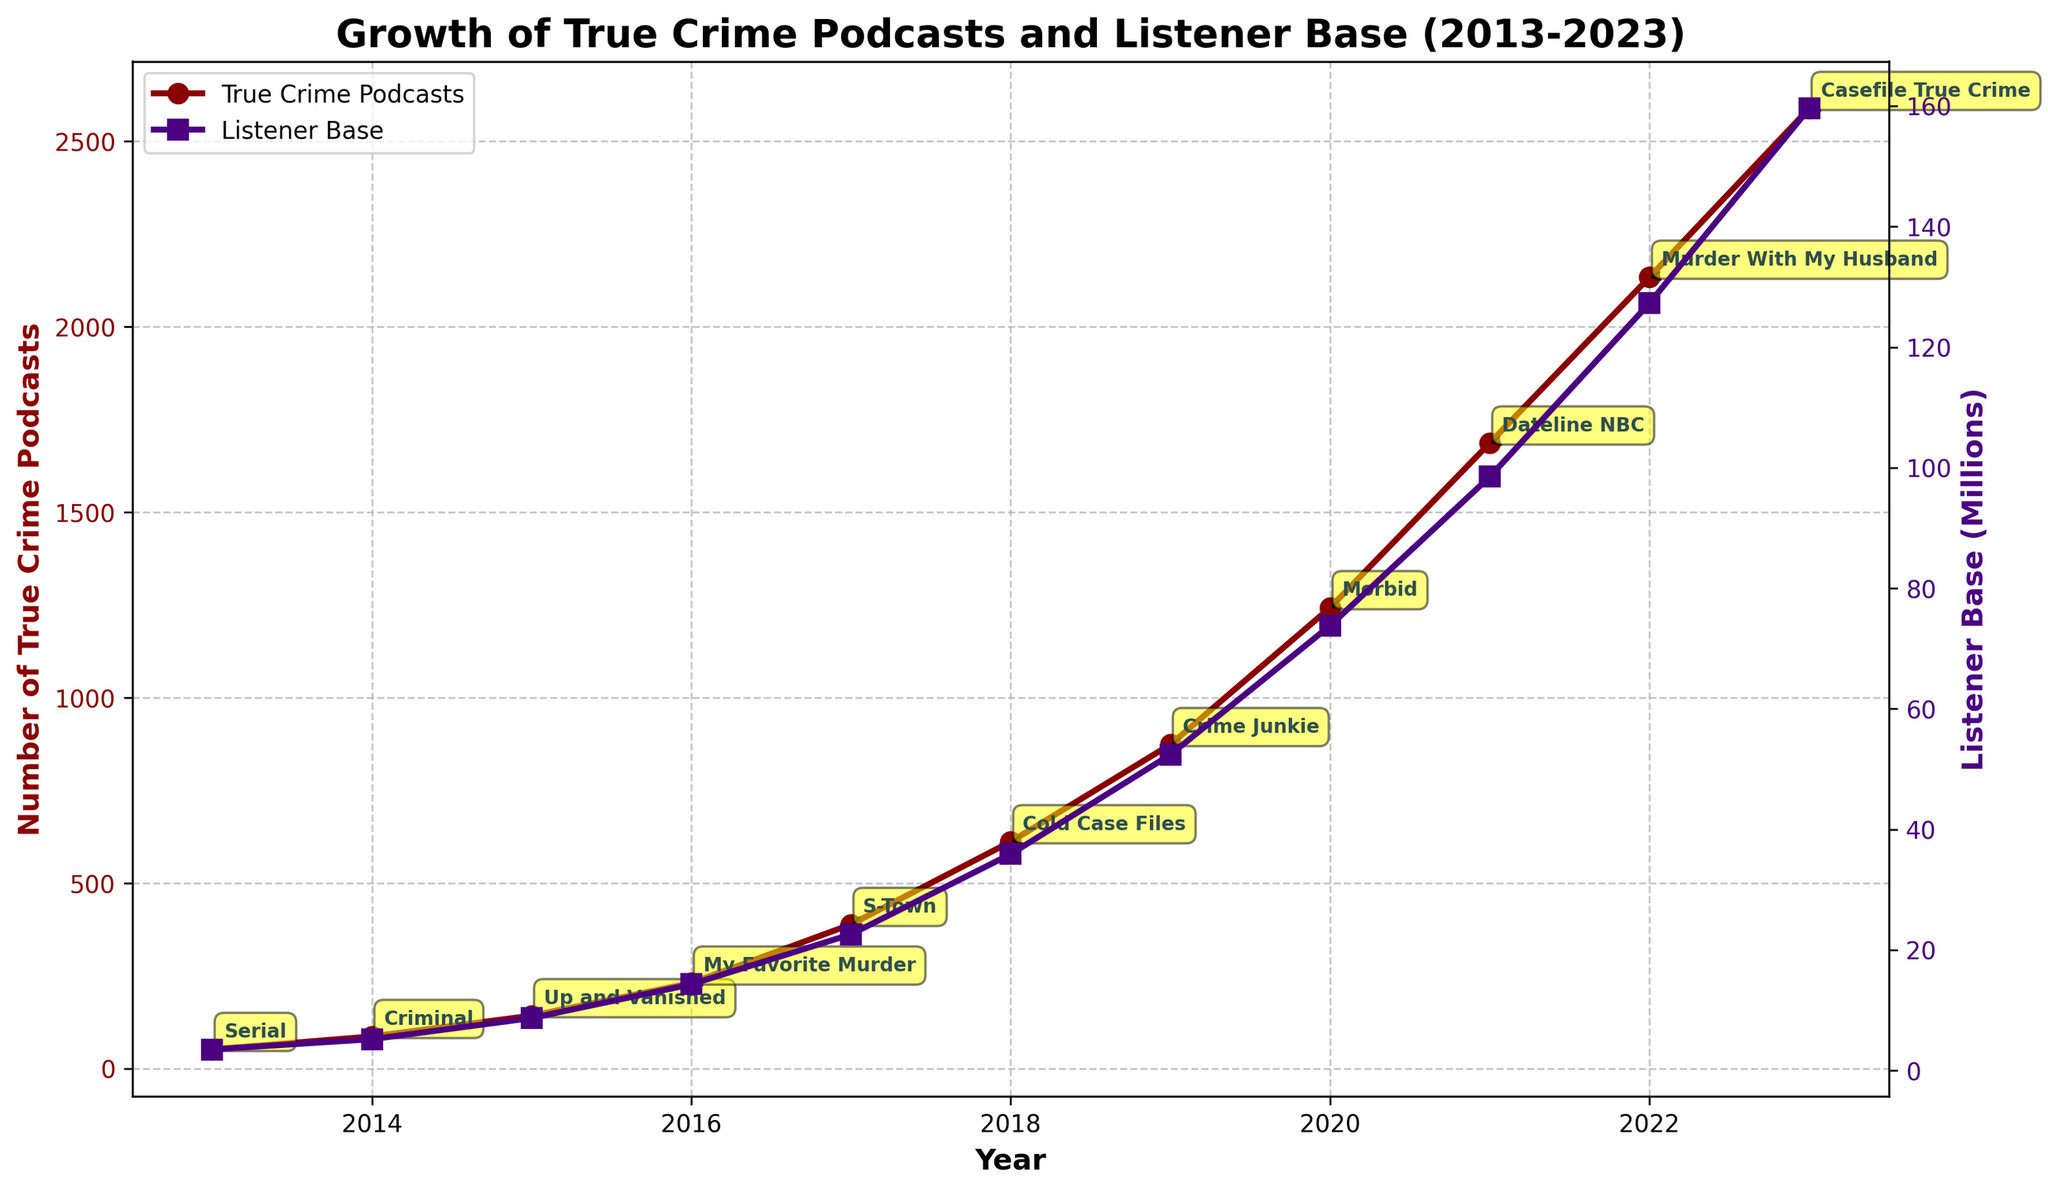What was the listener base in millions in 2017? To find the listener base in 2017, locate the year 2017 on the x-axis and refer to the y-axis on the right side, which shows the listener base in millions.
Answer: 22.6 In which year was there the greatest increase in the number of true crime podcasts compared to the previous year? Comparing the number of true crime podcasts each year and identifying the greatest numerical increase gives us the result. From 2020 to 2021, the number increased from 1243 to 1687, which is an increase of 444.
Answer: 2021 Which notable podcast was released in 2016, and how many true crime podcasts were there that year? Referring to the annotations in the figure, we can see which notable podcasts were mentioned in 2016. The number of true crime podcasts for that year can be found on the left y-axis.
Answer: My Favorite Murder, 231 By how much did the listener base grow from 2013 to 2023? Subtract the listener base in 2013 from the listener base in 2023. The listener base in 2013 was 3.5 million, and in 2023 it was 159.6 million. So, 159.6 - 3.5 = 156.1
Answer: 156.1 Which year had the closest number of listener base to 100 million and what is the exact listener base that year? Look at the listener base values near 100 million on the y-axis annotated on the right. Identify the year that has the closest value to 100 million.
Answer: 2021, 98.5 Over the decade, which came first: the podcast "Cold Case Files" or "Crime Junkie"? Refer to the annotations for notable podcasts and compare their positions on the x-axis to determine which was released first. "Cold Case Files" was released in 2018 and "Crime Junkie" in 2019.
Answer: Cold Case Files What was the average number of true crime podcasts between 2013 and 2017? Add up the number of true crime podcasts for the years 2013 to 2017 and divide by the number of years. (52 + 87 + 143 + 231 + 389) / 5 = 902 / 5
Answer: 180.4 How many years did it take for the listener base to exceed 100 million after 2013? Identify the year when the listener base first exceeds 100 million and subtract 2013 from that year. This occurred in 2021, so 2021 - 2013 = 8
Answer: 8 Which year showed a more significant increase in listener base: from 2018 to 2019 or from 2019 to 2020? Calculate the increase in listener base for both intervals. From 2018 to 2019: 52.4 - 35.9 = 16.5. From 2019 to 2020: 73.8 - 52.4 = 21.4. Compare the two values to find the greater increase.
Answer: from 2019 to 2020 